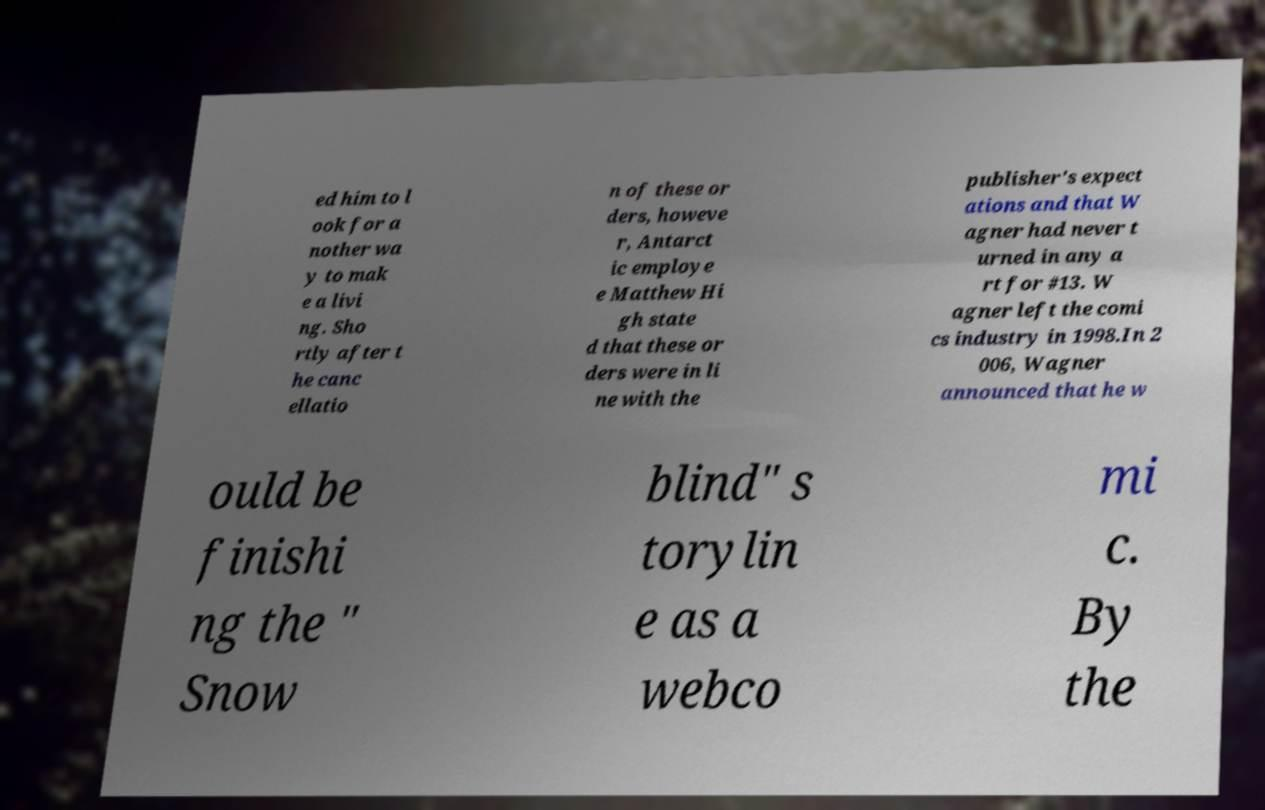Could you assist in decoding the text presented in this image and type it out clearly? ed him to l ook for a nother wa y to mak e a livi ng. Sho rtly after t he canc ellatio n of these or ders, howeve r, Antarct ic employe e Matthew Hi gh state d that these or ders were in li ne with the publisher's expect ations and that W agner had never t urned in any a rt for #13. W agner left the comi cs industry in 1998.In 2 006, Wagner announced that he w ould be finishi ng the " Snow blind" s torylin e as a webco mi c. By the 